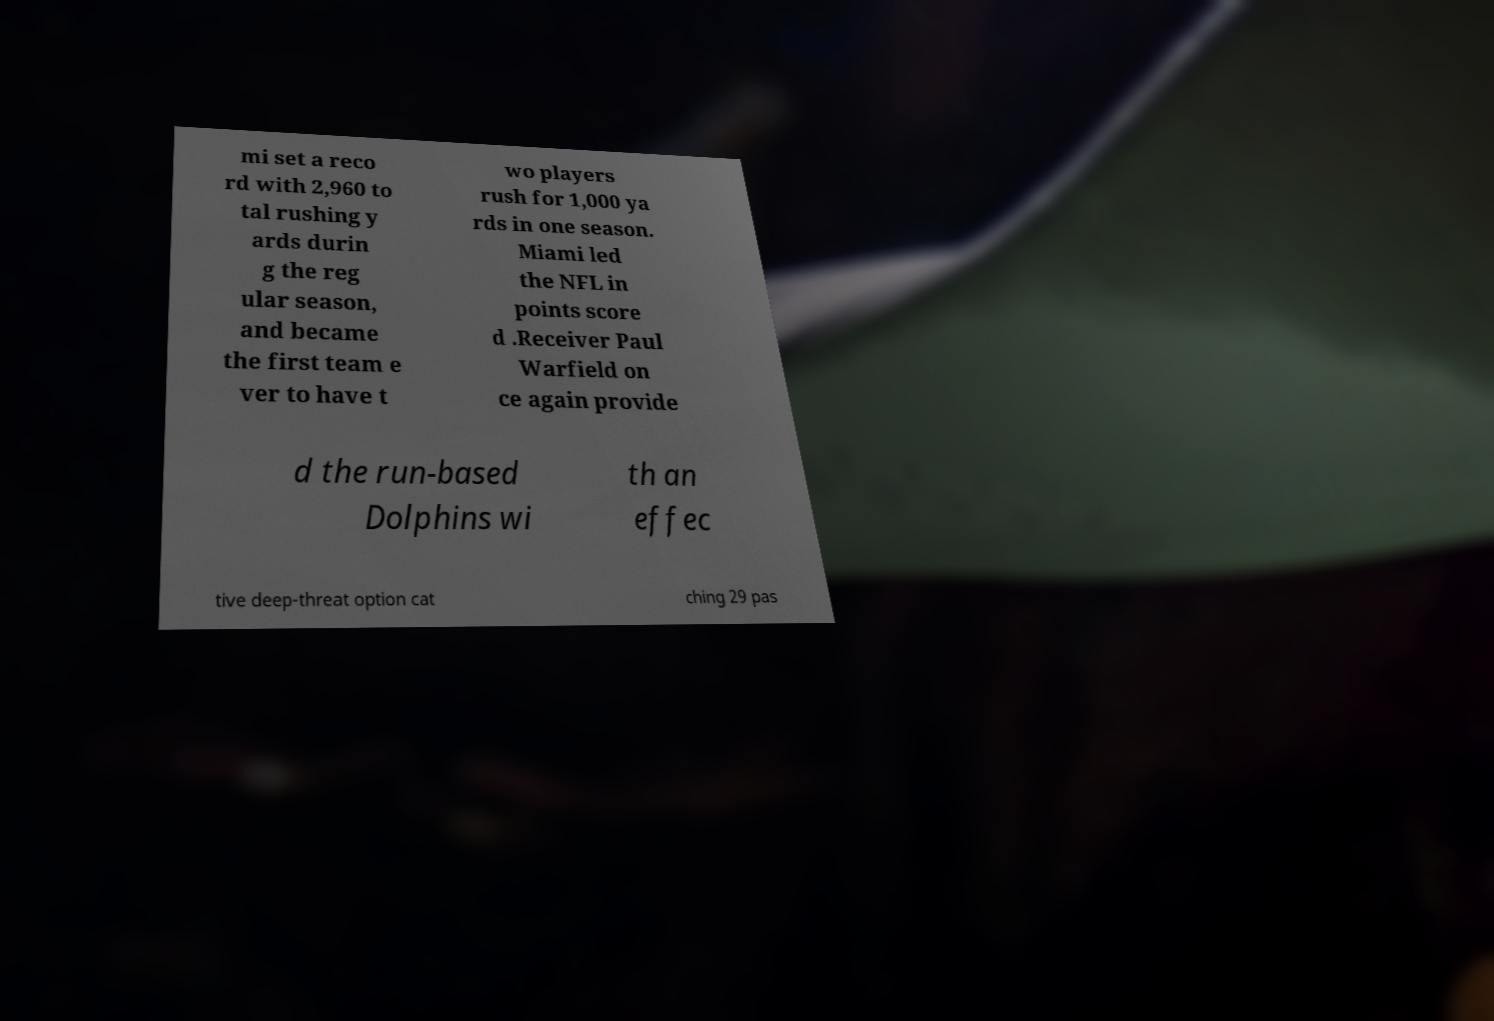I need the written content from this picture converted into text. Can you do that? mi set a reco rd with 2,960 to tal rushing y ards durin g the reg ular season, and became the first team e ver to have t wo players rush for 1,000 ya rds in one season. Miami led the NFL in points score d .Receiver Paul Warfield on ce again provide d the run-based Dolphins wi th an effec tive deep-threat option cat ching 29 pas 